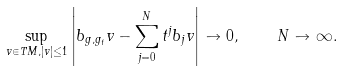<formula> <loc_0><loc_0><loc_500><loc_500>\sup _ { v \in T M , | v | \leq 1 } \left | b _ { g , g _ { t } } v - \sum _ { j = 0 } ^ { N } t ^ { j } b _ { j } v \right | \to 0 , \quad N \to \infty .</formula> 